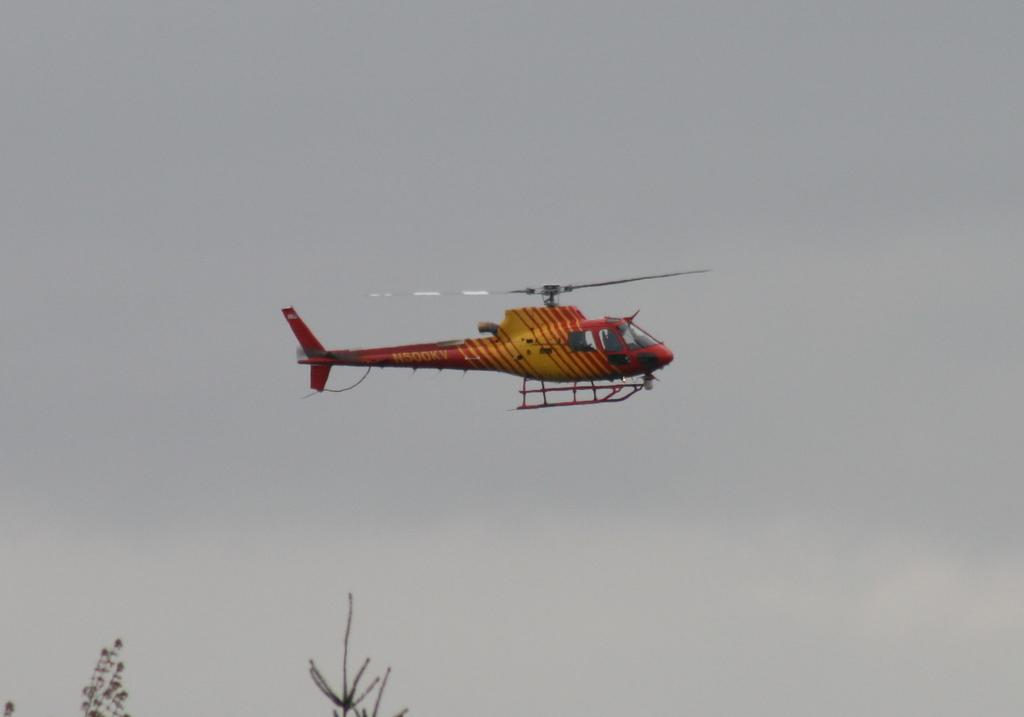What is the main subject of the image? There is a helicopter in the center of the image. What can be seen in the background of the image? There is sky visible in the background of the image, and there are clouds present. What is the taste of the helicopter in the image? Helicopters do not have a taste, as they are not edible objects. 